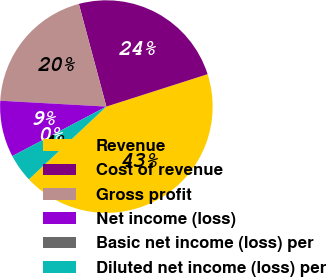Convert chart to OTSL. <chart><loc_0><loc_0><loc_500><loc_500><pie_chart><fcel>Revenue<fcel>Cost of revenue<fcel>Gross profit<fcel>Net income (loss)<fcel>Basic net income (loss) per<fcel>Diluted net income (loss) per<nl><fcel>42.93%<fcel>24.24%<fcel>19.95%<fcel>8.59%<fcel>0.0%<fcel>4.29%<nl></chart> 